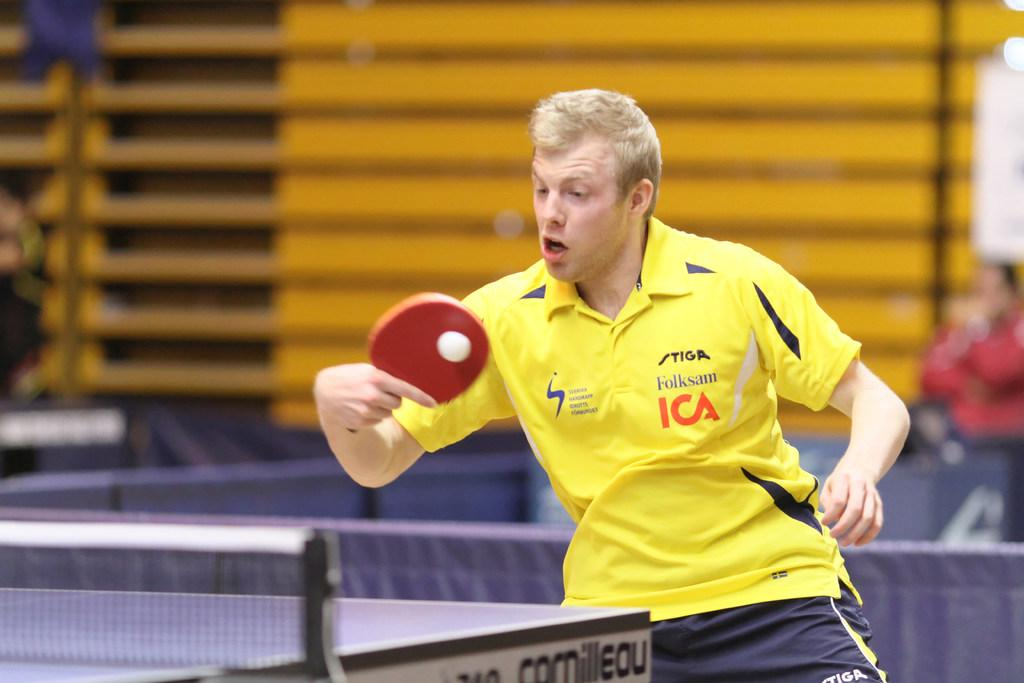<image>
Present a compact description of the photo's key features. A ping pong ball player wearing a yellow shirt with their sponsor Folksam's name on it. 